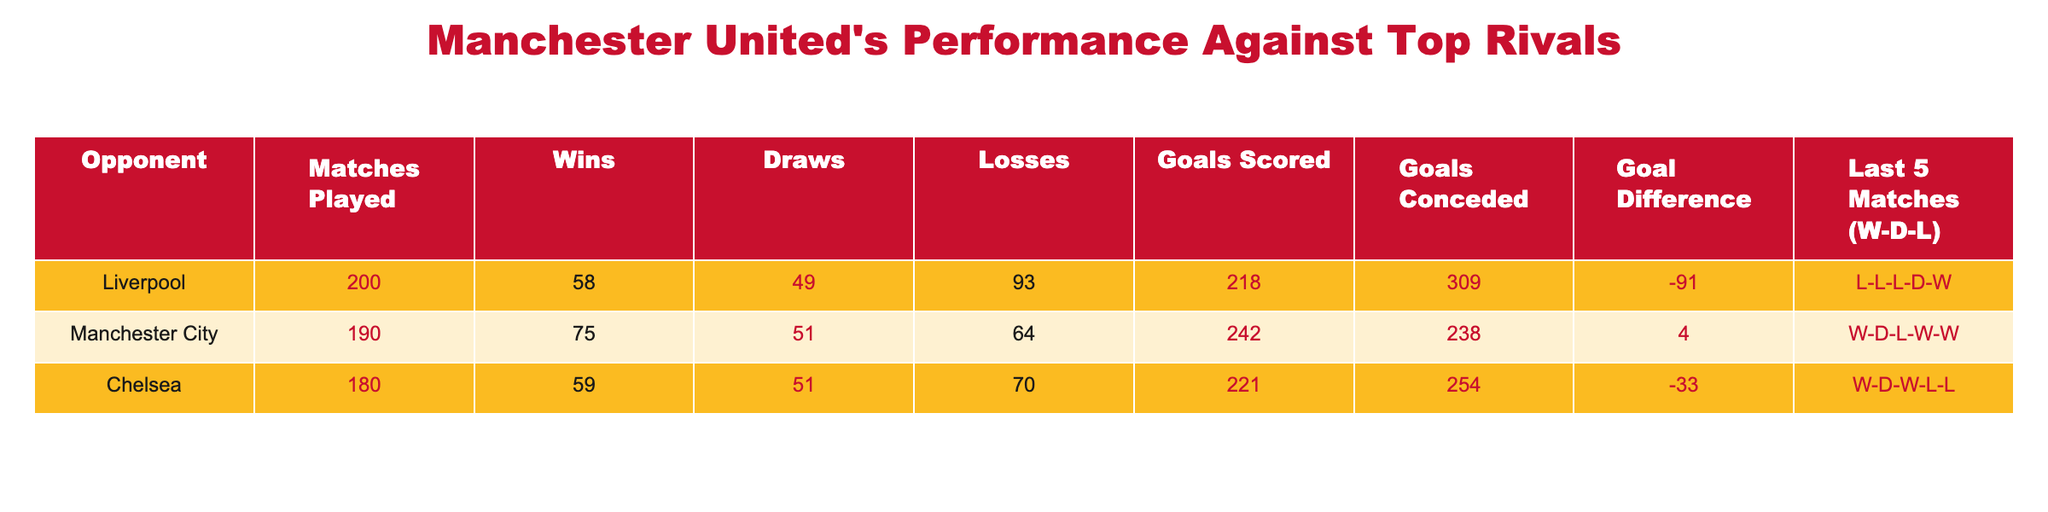What is Manchester United's total number of wins against Liverpool? The table shows that Manchester United has won 58 matches against Liverpool.
Answer: 58 What is the goal difference for Manchester United against Chelsea? The goal difference against Chelsea is calculated as Goals Scored (221) minus Goals Conceded (254), resulting in 221 - 254 = -33.
Answer: -33 How many matches has Manchester United drawn against Manchester City? The table lists the number of draws against Manchester City as 51.
Answer: 51 Is Manchester United's goal difference against Liverpool positive or negative? The goal difference against Liverpool is -91, which means it is negative.
Answer: Negative What is the total number of matches played by Manchester United against all three opponents combined? To find the total matches played, we add the matches against Liverpool (200), Manchester City (190), and Chelsea (180): 200 + 190 + 180 = 570.
Answer: 570 Which opponent has the highest number of wins against Manchester United? The number of losses against each opponent shows Liverpool has 93 losses for United, while City has 64, and Chelsea has 70 losses. Hence, Liverpool has the highest losses against Manchester United, meaning Utd has the most wins against Liverpool.
Answer: Liverpool How many more goals did Manchester United score against Manchester City than they conceded? The goal difference against Manchester City is calculated as Goals Scored (242) minus Goals Conceded (238), resulting in 242 - 238 = 4.
Answer: 4 In the last 5 matches against Liverpool, how many losses does Manchester United have? The last 5 matches against Liverpool are L-L-L-D-W, which shows that Manchester United has lost 3 out of 5 matches.
Answer: 3 What percentage of Manchester United's matches against Chelsea ended in draws? The percentage of drawn matches against Chelsea is calculated as (Draws (51) / Matches Played (180)) * 100 = 28.33%.
Answer: 28.33% 